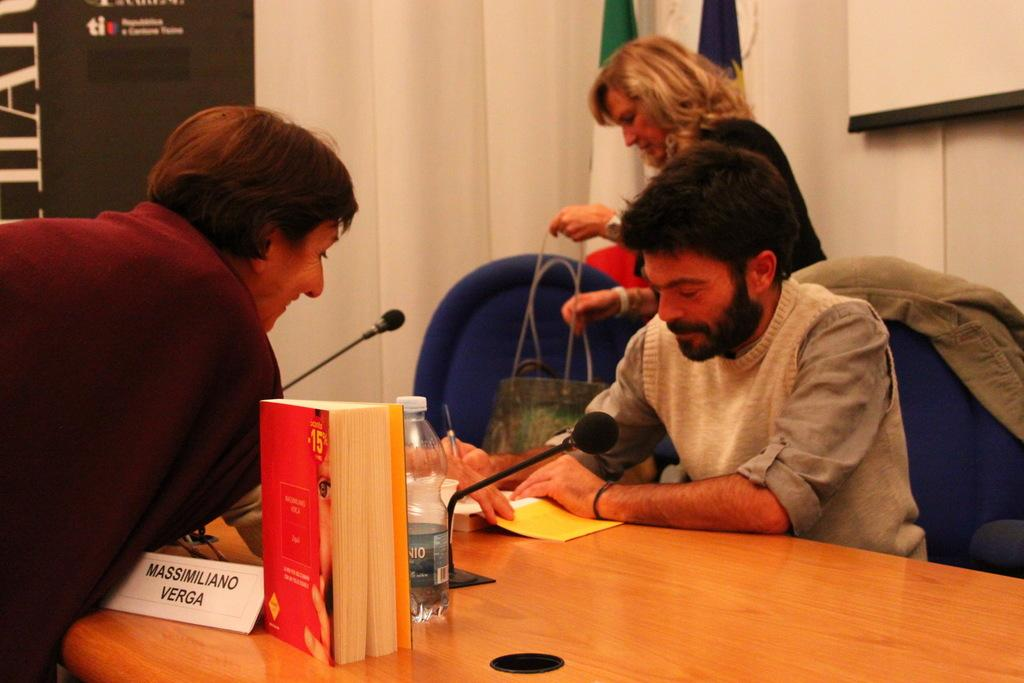<image>
Summarize the visual content of the image. A man is speaking at a table with a microphone and a sign that says Massimiliano Verga. 